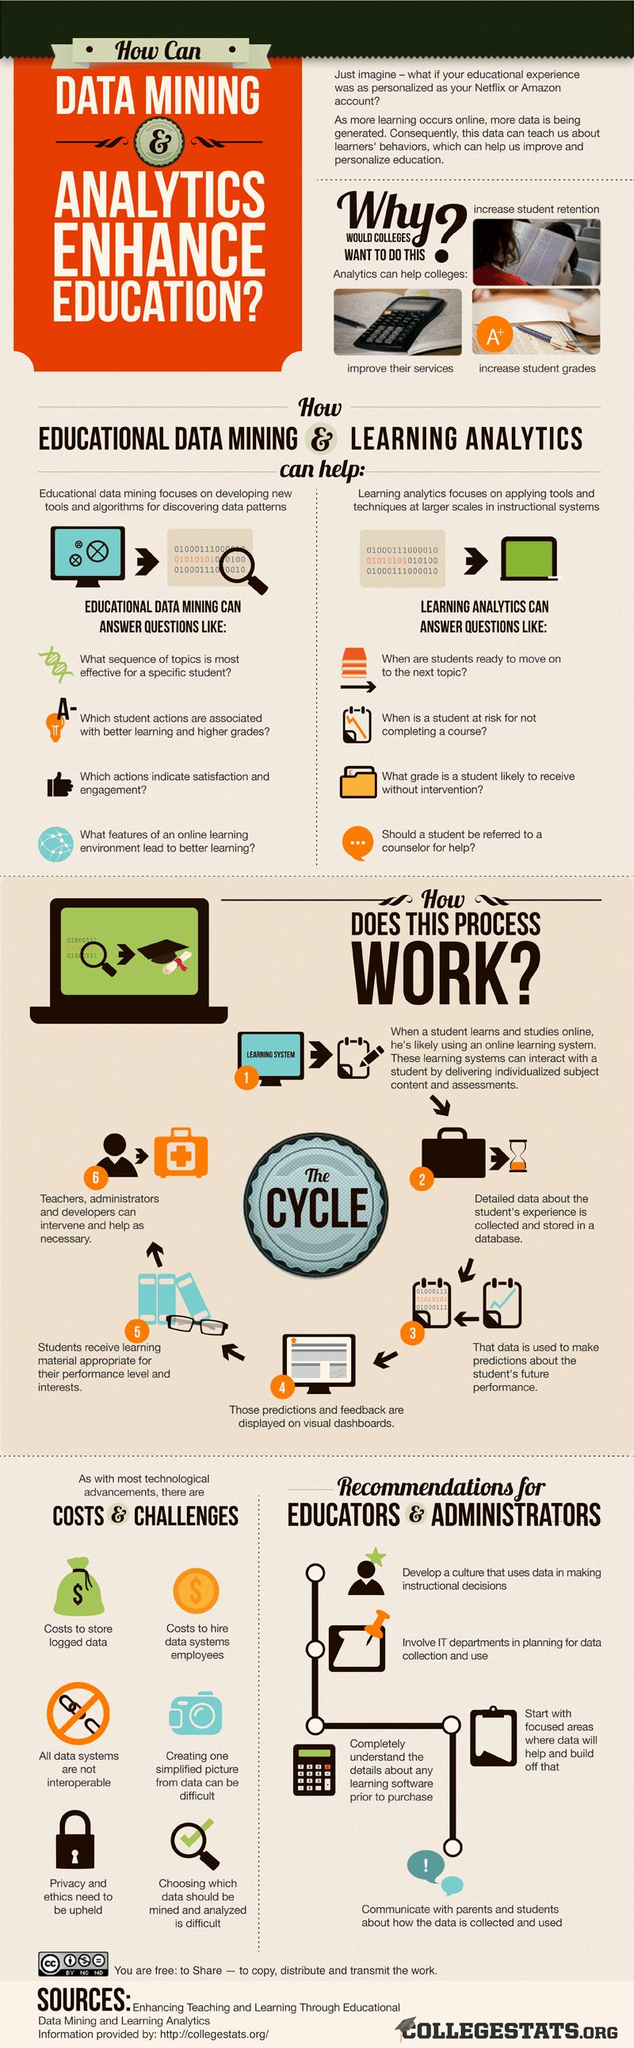List a handful of essential elements in this visual. The screen of the computer displays the message "Learning system..". Colleges aim to increase student retention and academic performance through the use of analytics. There are four recommendations provided for educators and administrators. 